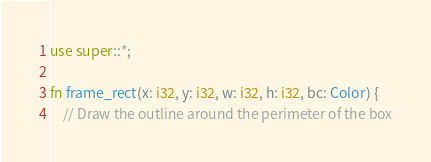Convert code to text. <code><loc_0><loc_0><loc_500><loc_500><_Rust_>use super::*;

fn frame_rect(x: i32, y: i32, w: i32, h: i32, bc: Color) {
    // Draw the outline around the perimeter of the box</code> 